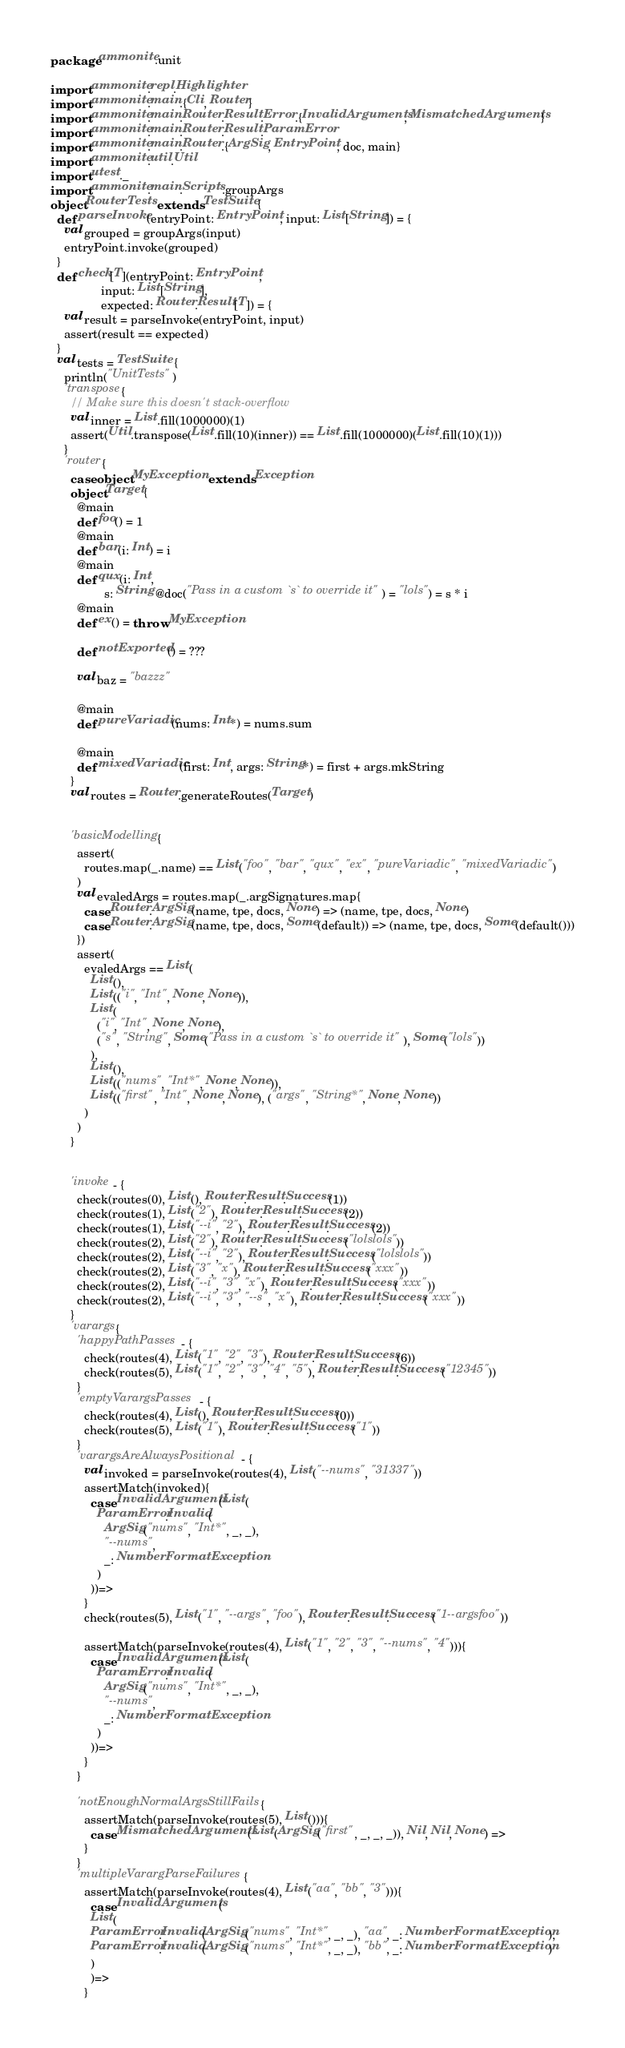<code> <loc_0><loc_0><loc_500><loc_500><_Scala_>package ammonite.unit

import ammonite.repl.Highlighter
import ammonite.main.{Cli, Router}
import ammonite.main.Router.Result.Error.{InvalidArguments, MismatchedArguments}
import ammonite.main.Router.Result.ParamError
import ammonite.main.Router.{ArgSig, EntryPoint, doc, main}
import ammonite.util.Util
import utest._
import ammonite.main.Scripts.groupArgs
object RouterTests extends TestSuite{
  def parseInvoke(entryPoint: EntryPoint, input: List[String]) = {
    val grouped = groupArgs(input)
    entryPoint.invoke(grouped)
  }
  def check[T](entryPoint: EntryPoint,
               input: List[String],
               expected: Router.Result[T]) = {
    val result = parseInvoke(entryPoint, input)
    assert(result == expected)
  }
  val tests = TestSuite {
    println("UnitTests")
    'transpose{
      // Make sure this doesn't stack-overflow
      val inner = List.fill(1000000)(1)
      assert(Util.transpose(List.fill(10)(inner)) == List.fill(1000000)(List.fill(10)(1)))
    }
    'router{
      case object MyException extends Exception
      object Target{
        @main
        def foo() = 1
        @main
        def bar(i: Int) = i
        @main
        def qux(i: Int,
                s: String @doc("Pass in a custom `s` to override it") = "lols") = s * i
        @main
        def ex() = throw MyException

        def notExported() = ???

        val baz = "bazzz"

        @main
        def pureVariadic(nums: Int*) = nums.sum

        @main
        def mixedVariadic(first: Int, args: String*) = first + args.mkString
      }
      val routes = Router.generateRoutes(Target)


      'basicModelling{
        assert(
          routes.map(_.name) == List("foo", "bar", "qux", "ex", "pureVariadic", "mixedVariadic")
        )
        val evaledArgs = routes.map(_.argSignatures.map{
          case Router.ArgSig(name, tpe, docs, None) => (name, tpe, docs, None)
          case Router.ArgSig(name, tpe, docs, Some(default)) => (name, tpe, docs, Some(default()))
        })
        assert(
          evaledArgs == List(
            List(),
            List(("i", "Int", None, None)),
            List(
              ("i", "Int", None, None),
              ("s", "String", Some("Pass in a custom `s` to override it"), Some("lols"))
            ),
            List(),
            List(("nums", "Int*", None, None)),
            List(("first", "Int", None, None), ("args", "String*", None, None))
          )
        )
      }


      'invoke - {
        check(routes(0), List(), Router.Result.Success(1))
        check(routes(1), List("2"), Router.Result.Success(2))
        check(routes(1), List("--i", "2"), Router.Result.Success(2))
        check(routes(2), List("2"), Router.Result.Success("lolslols"))
        check(routes(2), List("--i", "2"), Router.Result.Success("lolslols"))
        check(routes(2), List("3", "x"), Router.Result.Success("xxx"))
        check(routes(2), List("--i", "3", "x"), Router.Result.Success("xxx"))
        check(routes(2), List("--i", "3", "--s", "x"), Router.Result.Success("xxx"))
      }
      'varargs{
        'happyPathPasses - {
          check(routes(4), List("1", "2", "3"), Router.Result.Success(6))
          check(routes(5), List("1", "2", "3", "4", "5"), Router.Result.Success("12345"))
        }
        'emptyVarargsPasses - {
          check(routes(4), List(), Router.Result.Success(0))
          check(routes(5), List("1"), Router.Result.Success("1"))
        }
        'varargsAreAlwaysPositional - {
          val invoked = parseInvoke(routes(4), List("--nums", "31337"))
          assertMatch(invoked){
            case InvalidArguments(List(
              ParamError.Invalid(
                ArgSig("nums", "Int*", _, _),
                "--nums",
                _: NumberFormatException
              )
            ))=>
          }
          check(routes(5), List("1", "--args", "foo"), Router.Result.Success("1--argsfoo"))

          assertMatch(parseInvoke(routes(4), List("1", "2", "3", "--nums", "4"))){
            case InvalidArguments(List(
              ParamError.Invalid(
                ArgSig("nums", "Int*", _, _),
                "--nums",
                _: NumberFormatException
              )
            ))=>
          }
        }

        'notEnoughNormalArgsStillFails{
          assertMatch(parseInvoke(routes(5), List())){
            case MismatchedArguments(List(ArgSig("first", _, _, _)), Nil, Nil, None) =>
          }
        }
        'multipleVarargParseFailures{
          assertMatch(parseInvoke(routes(4), List("aa", "bb", "3"))){
            case InvalidArguments(
            List(
            ParamError.Invalid(ArgSig("nums", "Int*", _, _), "aa", _: NumberFormatException),
            ParamError.Invalid(ArgSig("nums", "Int*", _, _), "bb", _: NumberFormatException)
            )
            )=>
          }</code> 